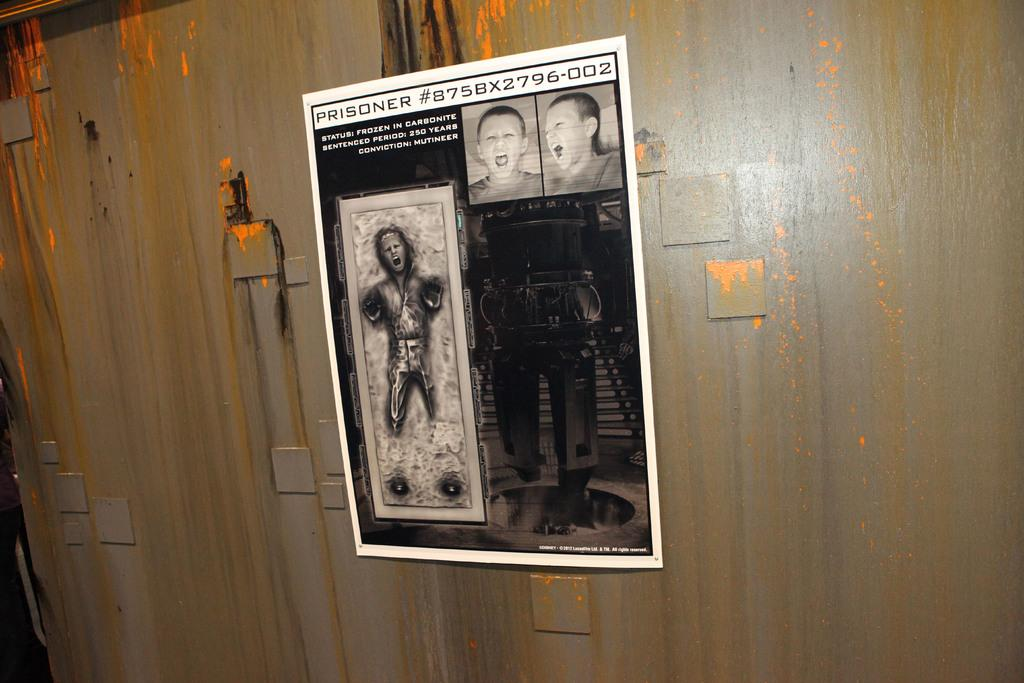<image>
Provide a brief description of the given image. A poster illustrating two faces of boys screaming and a skeletal looking man screaming with the words at the top saying PRISIONER #875BX2796-002. 